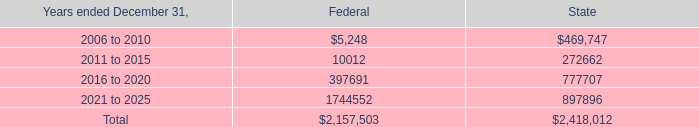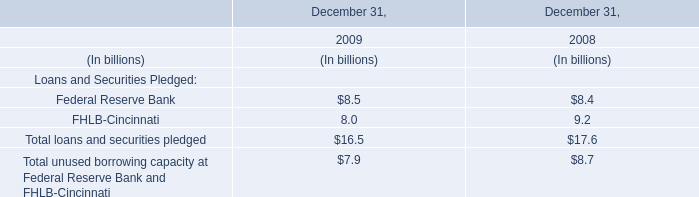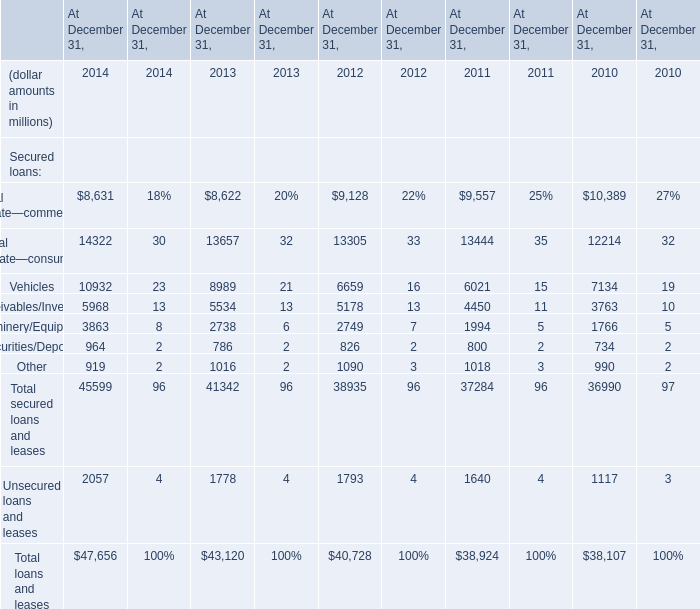what's the total amount of 2011 to 2015 of Federal, Machinery/Equipment of At December 31, 2010, and 2016 to 2020 of State ? 
Computations: ((10012.0 + 1766.0) + 777707.0)
Answer: 789485.0. 